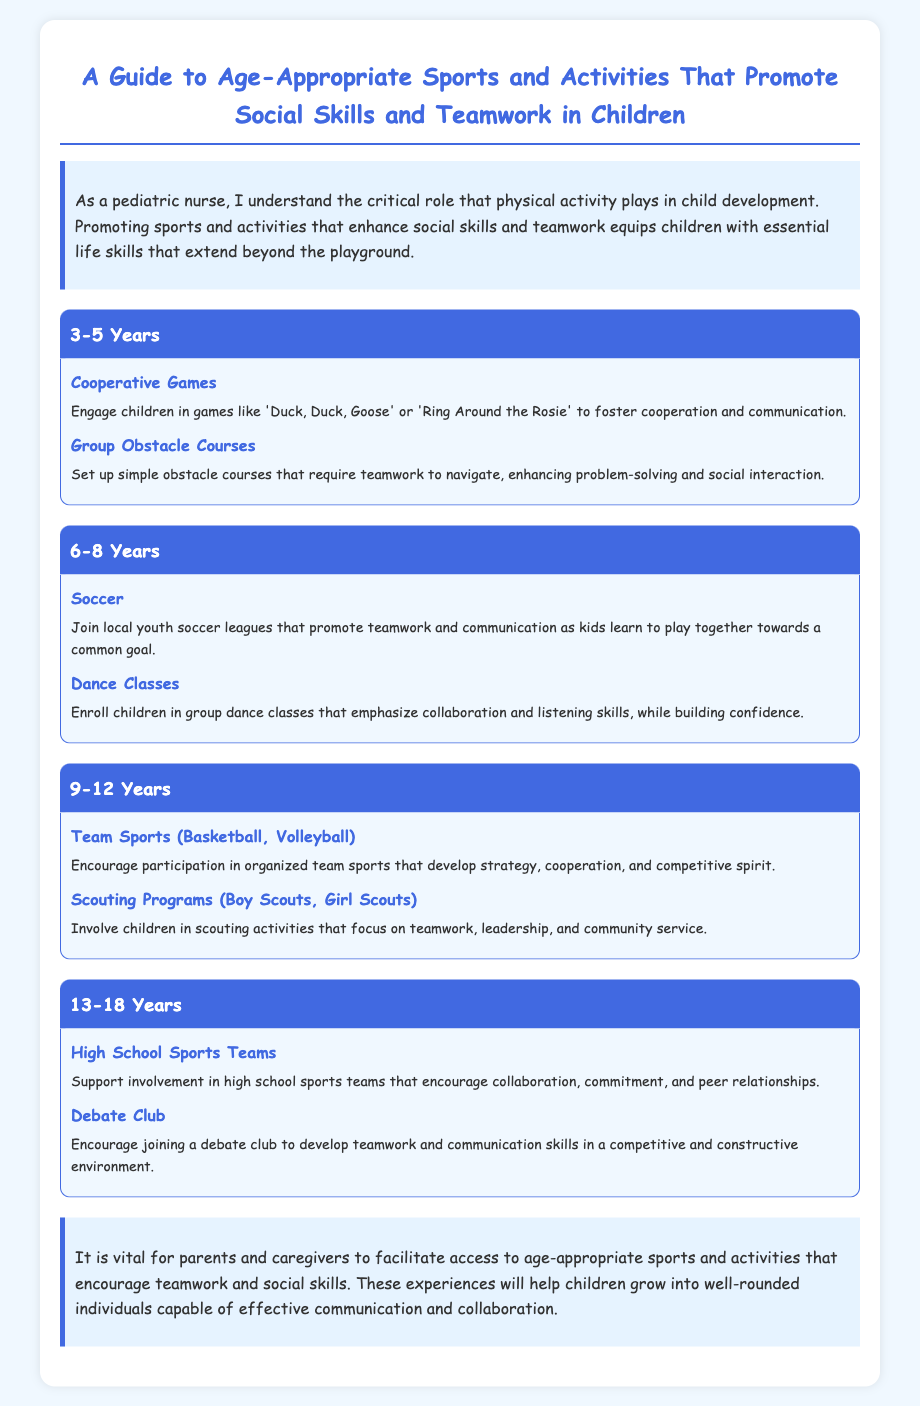What are two activities for children aged 3-5? The document lists "Cooperative Games" and "Group Obstacle Courses" as activities for this age group.
Answer: Cooperative Games, Group Obstacle Courses Which activity promotes teamwork for 6-8 year olds? The document mentions "Soccer" as a sport that promotes teamwork for children aged 6-8.
Answer: Soccer What is one benefit of participating in scouting programs for 9-12 year olds? "Scouting Programs" focus on teamwork, leadership, and community service, according to the document.
Answer: Teamwork, leadership, community service What should parents and caregivers facilitate? The document emphasizes that parents and caregivers should facilitate access to age-appropriate sports and activities.
Answer: Access to age-appropriate sports and activities What age group is encouraged to join high school sports teams? The document states that children aged 13-18 are encouraged to join high school sports teams.
Answer: 13-18 Years 